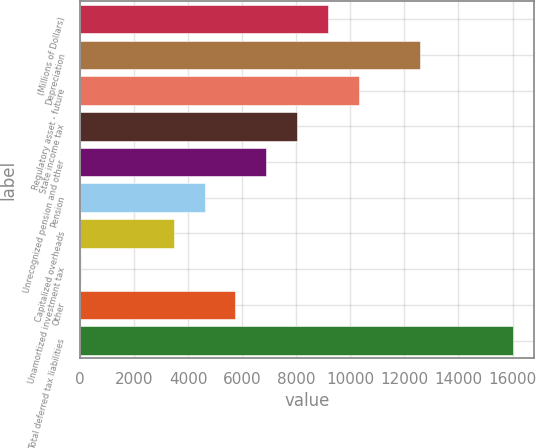<chart> <loc_0><loc_0><loc_500><loc_500><bar_chart><fcel>(Millions of Dollars)<fcel>Depreciation<fcel>Regulatory asset - future<fcel>State income tax<fcel>Unrecognized pension and other<fcel>Pension<fcel>Capitalized overheads<fcel>Unamortized investment tax<fcel>Other<fcel>Total deferred tax liabilities<nl><fcel>9166.2<fcel>12587.4<fcel>10306.6<fcel>8025.8<fcel>6885.4<fcel>4604.6<fcel>3464.2<fcel>43<fcel>5745<fcel>16008.6<nl></chart> 